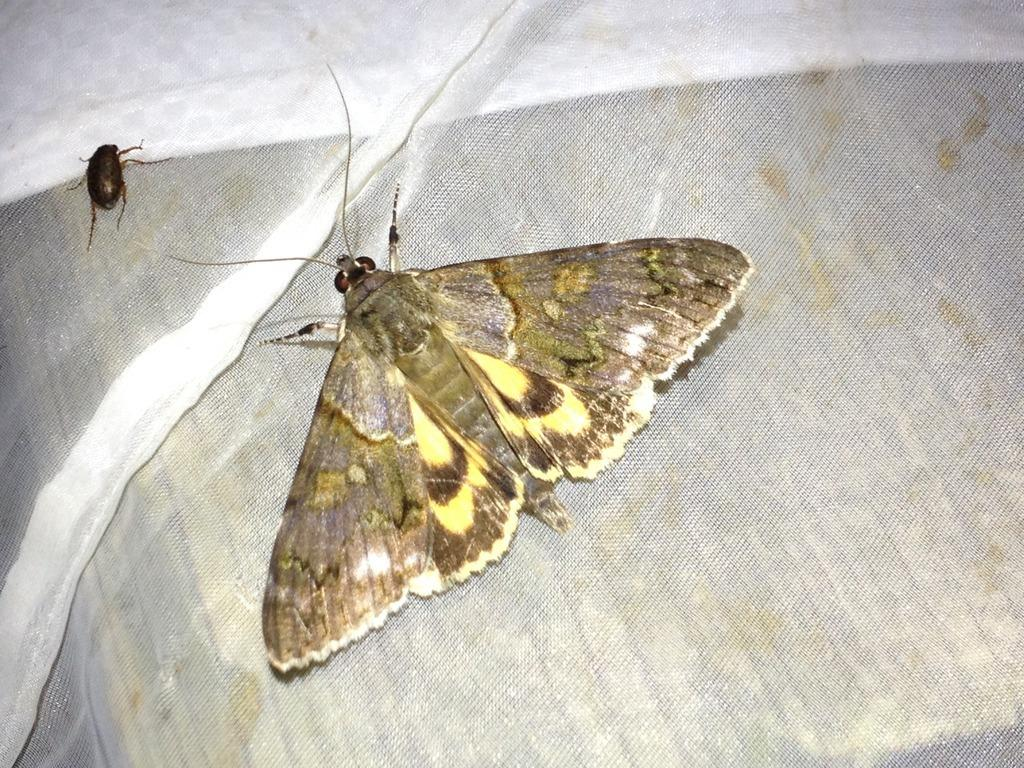How many insects are present in the image? There are two insects in the image. Where are the insects located? The insects are on a white cloth. What type of education is the insect receiving in the image? There is no indication in the image that the insects are receiving any education. 